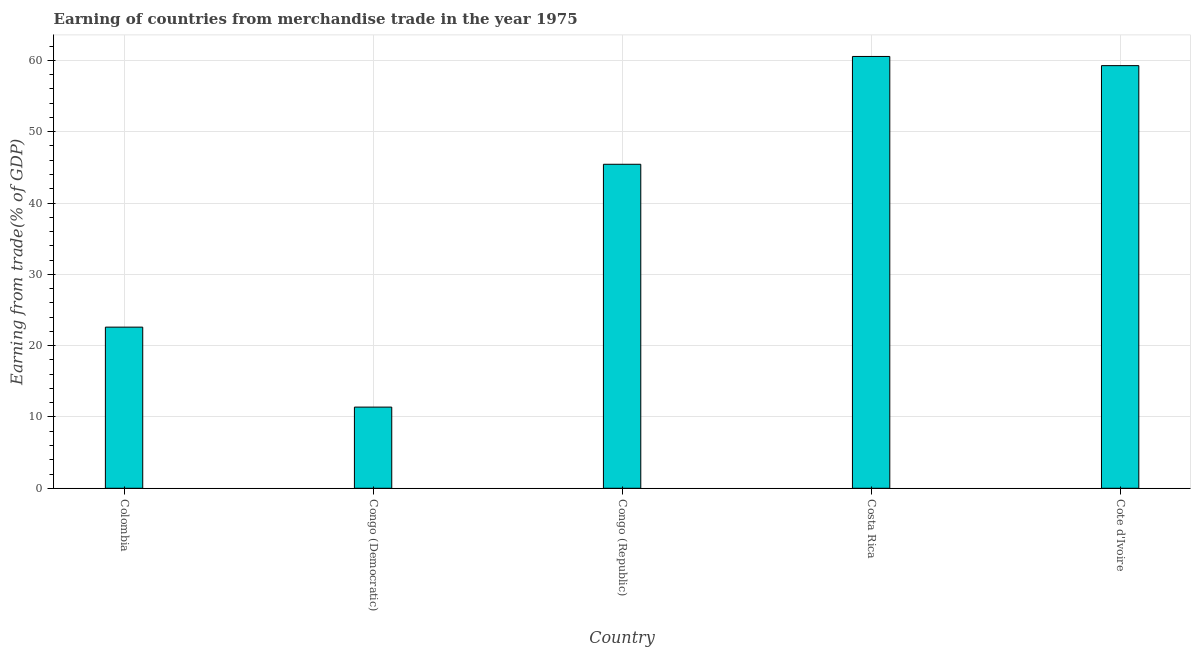Does the graph contain any zero values?
Offer a very short reply. No. What is the title of the graph?
Your response must be concise. Earning of countries from merchandise trade in the year 1975. What is the label or title of the X-axis?
Make the answer very short. Country. What is the label or title of the Y-axis?
Provide a short and direct response. Earning from trade(% of GDP). What is the earning from merchandise trade in Colombia?
Keep it short and to the point. 22.6. Across all countries, what is the maximum earning from merchandise trade?
Give a very brief answer. 60.55. Across all countries, what is the minimum earning from merchandise trade?
Give a very brief answer. 11.38. In which country was the earning from merchandise trade maximum?
Ensure brevity in your answer.  Costa Rica. In which country was the earning from merchandise trade minimum?
Provide a short and direct response. Congo (Democratic). What is the sum of the earning from merchandise trade?
Provide a short and direct response. 199.23. What is the difference between the earning from merchandise trade in Colombia and Congo (Republic)?
Your answer should be very brief. -22.84. What is the average earning from merchandise trade per country?
Keep it short and to the point. 39.84. What is the median earning from merchandise trade?
Your response must be concise. 45.43. In how many countries, is the earning from merchandise trade greater than 2 %?
Offer a terse response. 5. What is the ratio of the earning from merchandise trade in Congo (Republic) to that in Cote d'Ivoire?
Your answer should be very brief. 0.77. Is the difference between the earning from merchandise trade in Colombia and Congo (Democratic) greater than the difference between any two countries?
Ensure brevity in your answer.  No. What is the difference between the highest and the second highest earning from merchandise trade?
Your response must be concise. 1.28. What is the difference between the highest and the lowest earning from merchandise trade?
Your answer should be compact. 49.17. In how many countries, is the earning from merchandise trade greater than the average earning from merchandise trade taken over all countries?
Your answer should be very brief. 3. How many countries are there in the graph?
Keep it short and to the point. 5. What is the difference between two consecutive major ticks on the Y-axis?
Your answer should be compact. 10. What is the Earning from trade(% of GDP) of Colombia?
Your answer should be compact. 22.6. What is the Earning from trade(% of GDP) of Congo (Democratic)?
Make the answer very short. 11.38. What is the Earning from trade(% of GDP) in Congo (Republic)?
Offer a very short reply. 45.43. What is the Earning from trade(% of GDP) of Costa Rica?
Provide a succinct answer. 60.55. What is the Earning from trade(% of GDP) in Cote d'Ivoire?
Provide a short and direct response. 59.26. What is the difference between the Earning from trade(% of GDP) in Colombia and Congo (Democratic)?
Make the answer very short. 11.21. What is the difference between the Earning from trade(% of GDP) in Colombia and Congo (Republic)?
Your answer should be very brief. -22.84. What is the difference between the Earning from trade(% of GDP) in Colombia and Costa Rica?
Your answer should be compact. -37.95. What is the difference between the Earning from trade(% of GDP) in Colombia and Cote d'Ivoire?
Provide a short and direct response. -36.67. What is the difference between the Earning from trade(% of GDP) in Congo (Democratic) and Congo (Republic)?
Make the answer very short. -34.05. What is the difference between the Earning from trade(% of GDP) in Congo (Democratic) and Costa Rica?
Offer a terse response. -49.17. What is the difference between the Earning from trade(% of GDP) in Congo (Democratic) and Cote d'Ivoire?
Give a very brief answer. -47.88. What is the difference between the Earning from trade(% of GDP) in Congo (Republic) and Costa Rica?
Your answer should be very brief. -15.12. What is the difference between the Earning from trade(% of GDP) in Congo (Republic) and Cote d'Ivoire?
Your answer should be compact. -13.83. What is the difference between the Earning from trade(% of GDP) in Costa Rica and Cote d'Ivoire?
Offer a very short reply. 1.29. What is the ratio of the Earning from trade(% of GDP) in Colombia to that in Congo (Democratic)?
Give a very brief answer. 1.99. What is the ratio of the Earning from trade(% of GDP) in Colombia to that in Congo (Republic)?
Provide a short and direct response. 0.5. What is the ratio of the Earning from trade(% of GDP) in Colombia to that in Costa Rica?
Your response must be concise. 0.37. What is the ratio of the Earning from trade(% of GDP) in Colombia to that in Cote d'Ivoire?
Keep it short and to the point. 0.38. What is the ratio of the Earning from trade(% of GDP) in Congo (Democratic) to that in Congo (Republic)?
Provide a succinct answer. 0.25. What is the ratio of the Earning from trade(% of GDP) in Congo (Democratic) to that in Costa Rica?
Provide a short and direct response. 0.19. What is the ratio of the Earning from trade(% of GDP) in Congo (Democratic) to that in Cote d'Ivoire?
Your answer should be compact. 0.19. What is the ratio of the Earning from trade(% of GDP) in Congo (Republic) to that in Costa Rica?
Your answer should be compact. 0.75. What is the ratio of the Earning from trade(% of GDP) in Congo (Republic) to that in Cote d'Ivoire?
Provide a short and direct response. 0.77. 